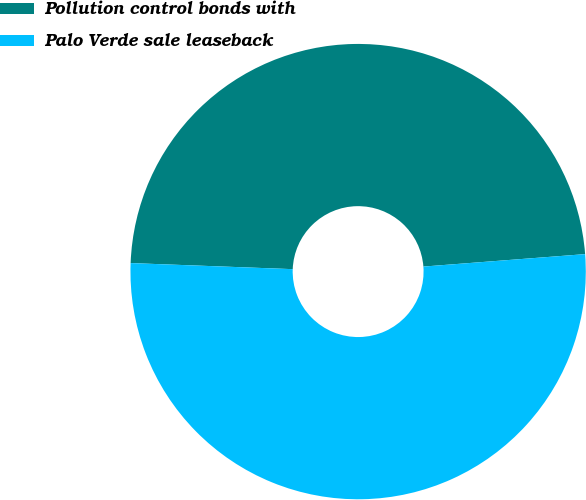Convert chart. <chart><loc_0><loc_0><loc_500><loc_500><pie_chart><fcel>Pollution control bonds with<fcel>Palo Verde sale leaseback<nl><fcel>48.18%<fcel>51.82%<nl></chart> 